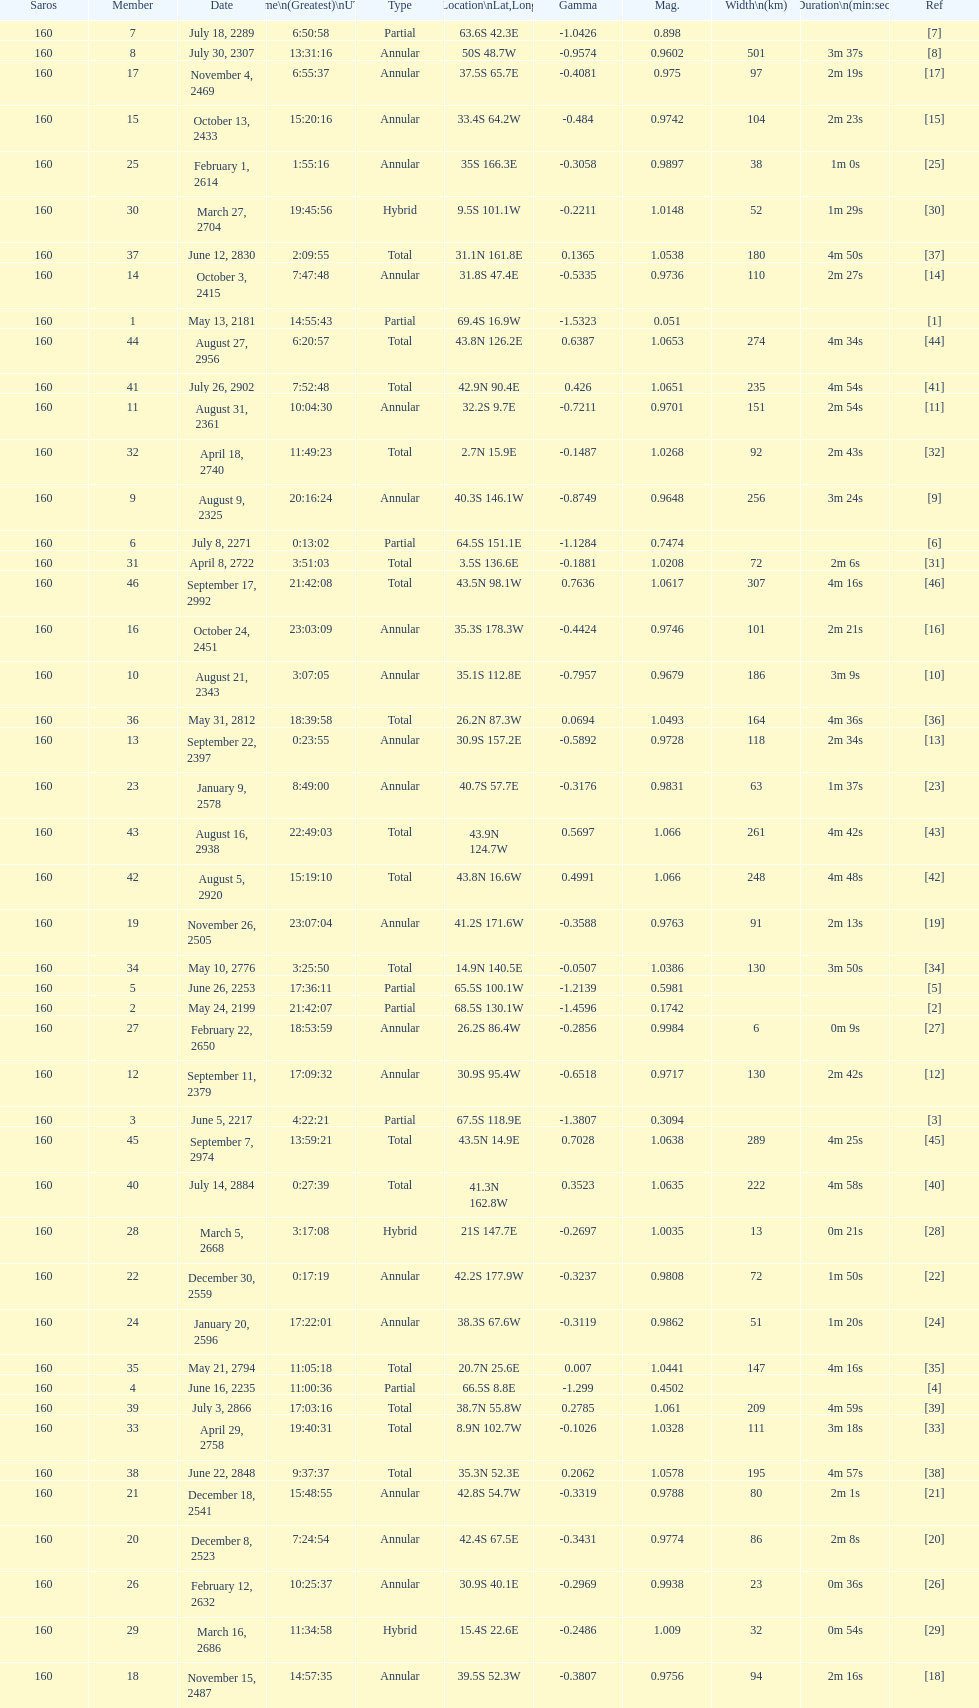How long did the the saros on july 30, 2307 last for? 3m 37s. 